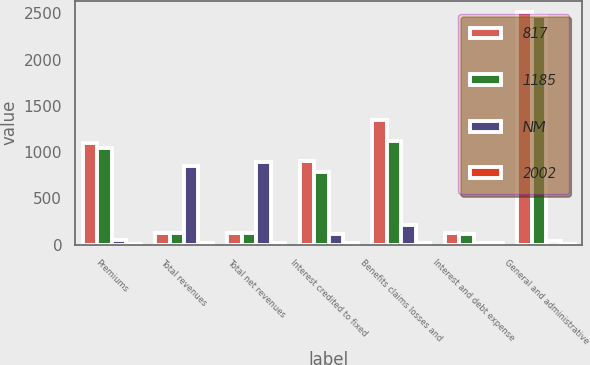Convert chart. <chart><loc_0><loc_0><loc_500><loc_500><stacked_bar_chart><ecel><fcel>Premiums<fcel>Total revenues<fcel>Total net revenues<fcel>Interest credited to fixed<fcel>Benefits claims losses and<fcel>Interest and debt expense<fcel>General and administrative<nl><fcel>817<fcel>1098<fcel>120<fcel>120<fcel>903<fcel>1342<fcel>127<fcel>2514<nl><fcel>1185<fcel>1048<fcel>120<fcel>120<fcel>790<fcel>1125<fcel>109<fcel>2472<nl><fcel>NM<fcel>50<fcel>851<fcel>889<fcel>113<fcel>217<fcel>18<fcel>42<nl><fcel>2002<fcel>5<fcel>12<fcel>13<fcel>14<fcel>19<fcel>17<fcel>2<nl></chart> 